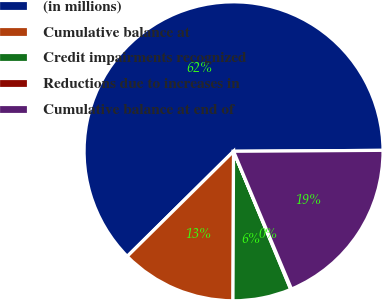Convert chart to OTSL. <chart><loc_0><loc_0><loc_500><loc_500><pie_chart><fcel>(in millions)<fcel>Cumulative balance at<fcel>Credit impairments recognized<fcel>Reductions due to increases in<fcel>Cumulative balance at end of<nl><fcel>62.3%<fcel>12.53%<fcel>6.31%<fcel>0.09%<fcel>18.76%<nl></chart> 